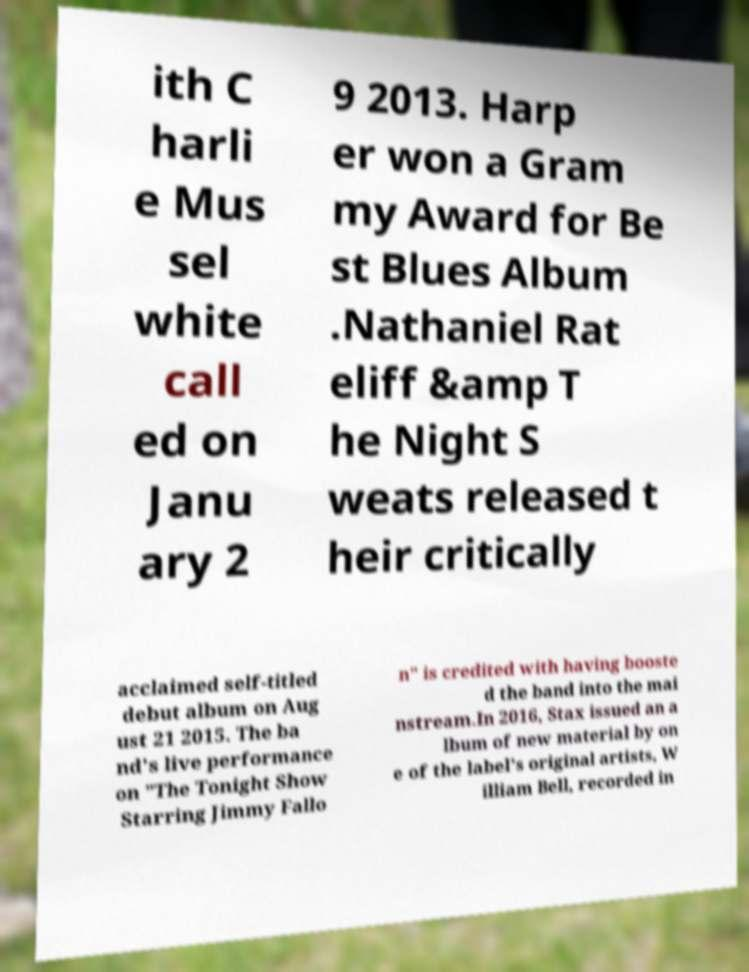I need the written content from this picture converted into text. Can you do that? ith C harli e Mus sel white call ed on Janu ary 2 9 2013. Harp er won a Gram my Award for Be st Blues Album .Nathaniel Rat eliff &amp T he Night S weats released t heir critically acclaimed self-titled debut album on Aug ust 21 2015. The ba nd's live performance on "The Tonight Show Starring Jimmy Fallo n" is credited with having booste d the band into the mai nstream.In 2016, Stax issued an a lbum of new material by on e of the label's original artists, W illiam Bell, recorded in 